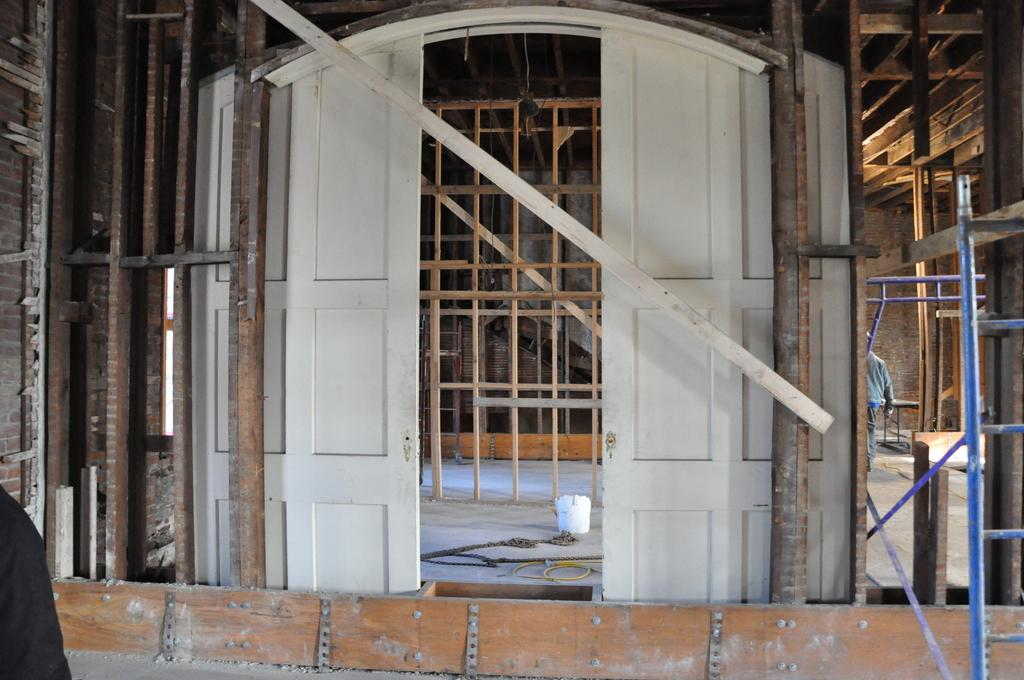What color are the doors in the image? The doors in the image are white. What color is the ceiling in the image? The ceiling is white in the image. Can you describe the person in the image? There is a person in the image, but no specific details about their appearance or actions are provided. What type of structure is visible in the image? The image shows a wall, which suggests it is an inside view of a building. What other objects can be seen in the image? There are other objects visible in the image, but no specific details are provided. What type of boats are visible in the image? There are no boats present in the image; it is an inside view of a building. What type of approval is required for the person in the image? There is no indication of any approval process in the image, as it only shows a person and some objects in a room. 